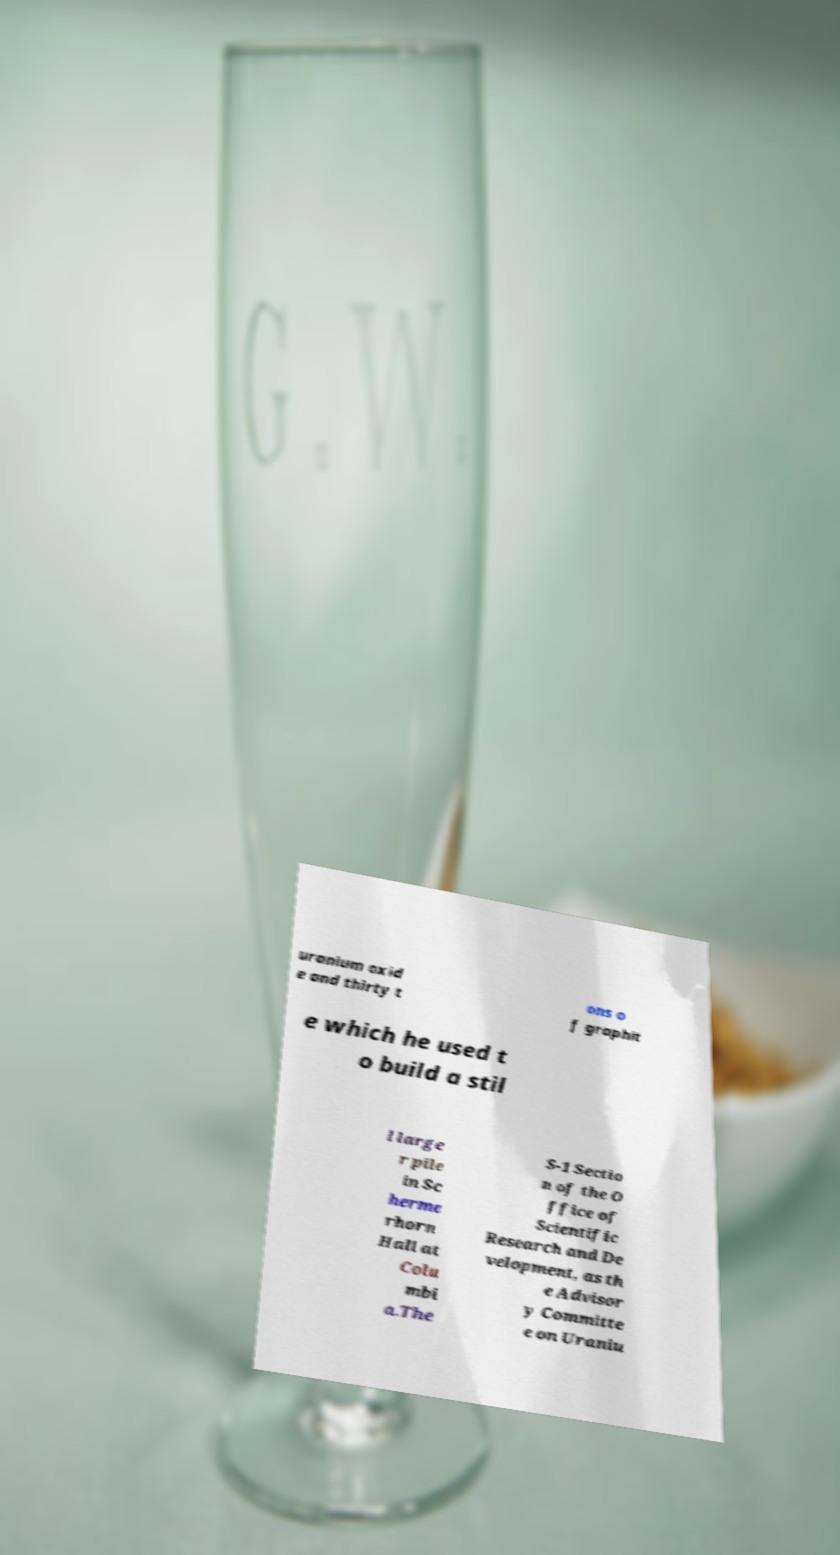Could you assist in decoding the text presented in this image and type it out clearly? uranium oxid e and thirty t ons o f graphit e which he used t o build a stil l large r pile in Sc herme rhorn Hall at Colu mbi a.The S-1 Sectio n of the O ffice of Scientific Research and De velopment, as th e Advisor y Committe e on Uraniu 